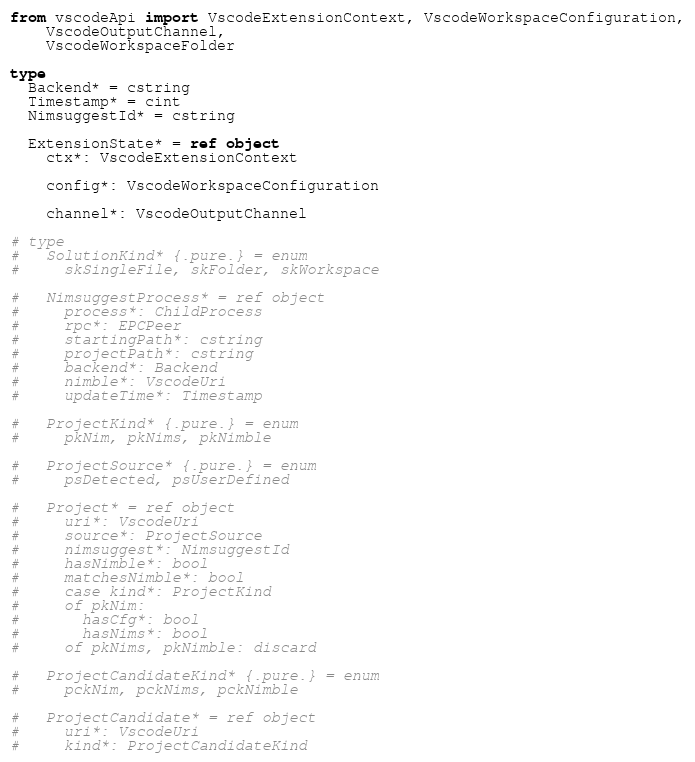<code> <loc_0><loc_0><loc_500><loc_500><_Nim_>from vscodeApi import VscodeExtensionContext, VscodeWorkspaceConfiguration,
    VscodeOutputChannel,
    VscodeWorkspaceFolder

type
  Backend* = cstring
  Timestamp* = cint
  NimsuggestId* = cstring

  ExtensionState* = ref object
    ctx*: VscodeExtensionContext

    config*: VscodeWorkspaceConfiguration

    channel*: VscodeOutputChannel

# type
#   SolutionKind* {.pure.} = enum
#     skSingleFile, skFolder, skWorkspace

#   NimsuggestProcess* = ref object
#     process*: ChildProcess
#     rpc*: EPCPeer
#     startingPath*: cstring
#     projectPath*: cstring
#     backend*: Backend
#     nimble*: VscodeUri
#     updateTime*: Timestamp
  
#   ProjectKind* {.pure.} = enum
#     pkNim, pkNims, pkNimble

#   ProjectSource* {.pure.} = enum
#     psDetected, psUserDefined

#   Project* = ref object
#     uri*: VscodeUri
#     source*: ProjectSource
#     nimsuggest*: NimsuggestId
#     hasNimble*: bool
#     matchesNimble*: bool
#     case kind*: ProjectKind
#     of pkNim:
#       hasCfg*: bool
#       hasNims*: bool
#     of pkNims, pkNimble: discard

#   ProjectCandidateKind* {.pure.} = enum
#     pckNim, pckNims, pckNimble

#   ProjectCandidate* = ref object
#     uri*: VscodeUri
#     kind*: ProjectCandidateKind</code> 